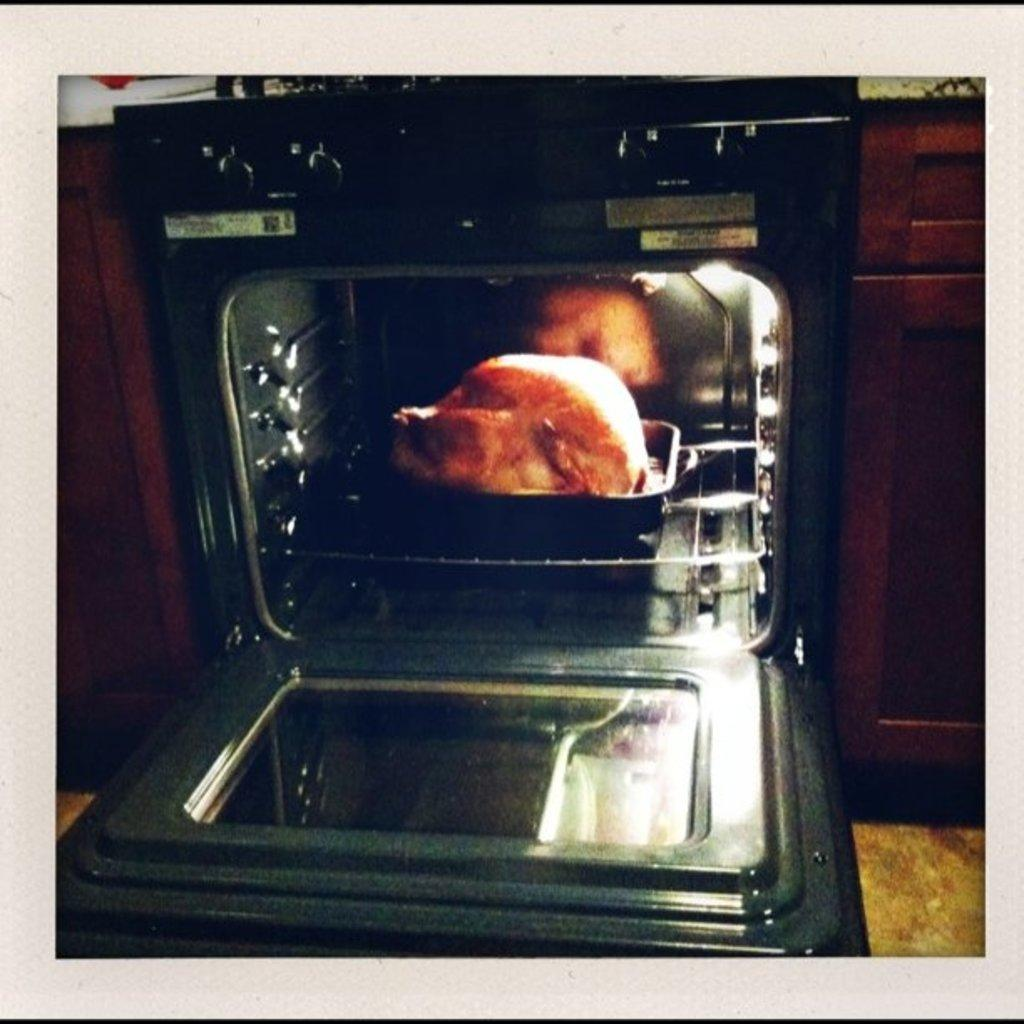What type of appliance is present in the image? There is an oven in the image. What is inside the oven? There is a tray in the oven. What is on the tray inside the oven? There is chicken on the tray. What type of sweater is the authority figure wearing in the image? There is no authority figure or sweater present in the image; it only features an oven, a tray, and chicken. 